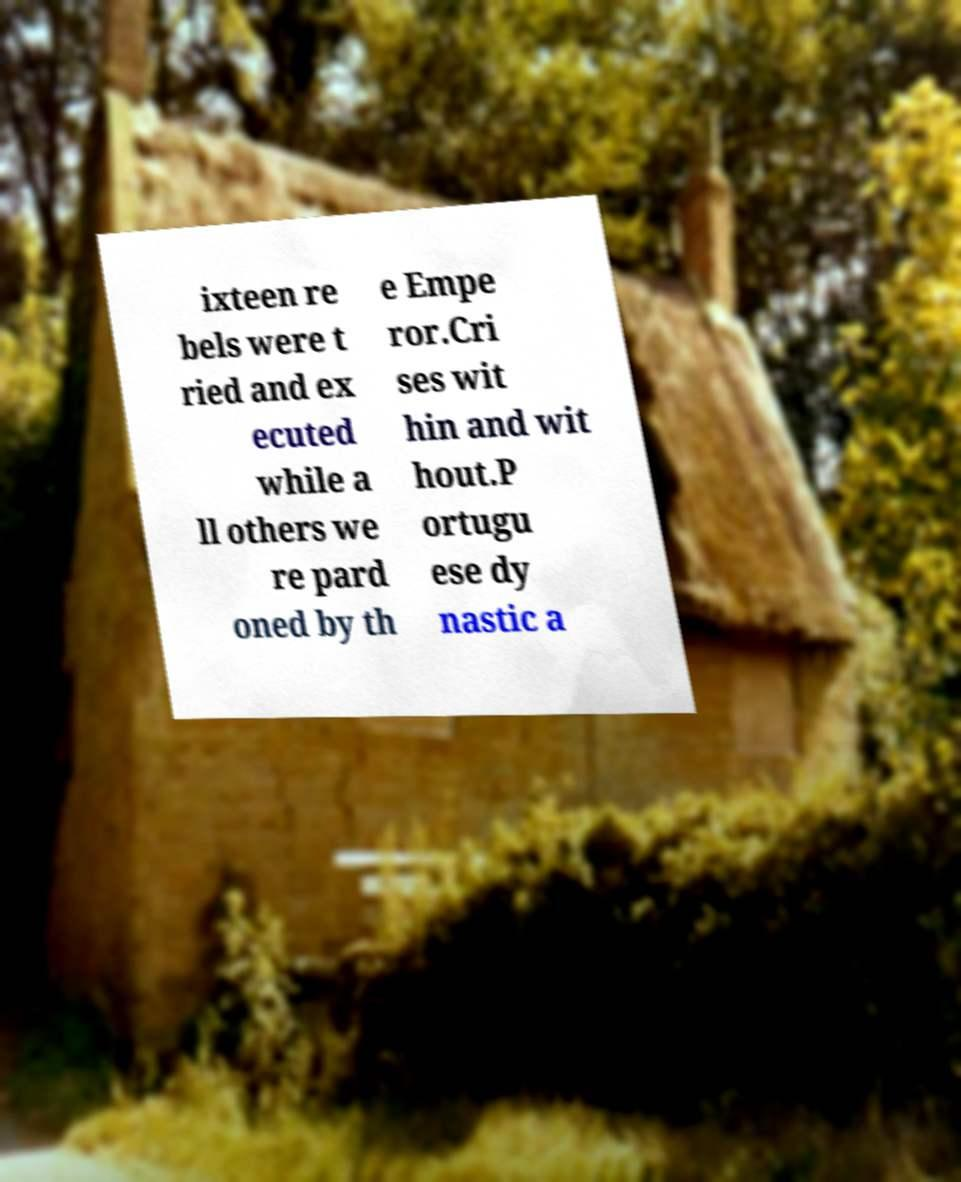What messages or text are displayed in this image? I need them in a readable, typed format. ixteen re bels were t ried and ex ecuted while a ll others we re pard oned by th e Empe ror.Cri ses wit hin and wit hout.P ortugu ese dy nastic a 